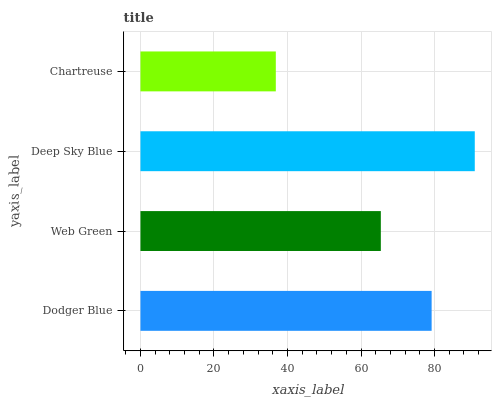Is Chartreuse the minimum?
Answer yes or no. Yes. Is Deep Sky Blue the maximum?
Answer yes or no. Yes. Is Web Green the minimum?
Answer yes or no. No. Is Web Green the maximum?
Answer yes or no. No. Is Dodger Blue greater than Web Green?
Answer yes or no. Yes. Is Web Green less than Dodger Blue?
Answer yes or no. Yes. Is Web Green greater than Dodger Blue?
Answer yes or no. No. Is Dodger Blue less than Web Green?
Answer yes or no. No. Is Dodger Blue the high median?
Answer yes or no. Yes. Is Web Green the low median?
Answer yes or no. Yes. Is Web Green the high median?
Answer yes or no. No. Is Deep Sky Blue the low median?
Answer yes or no. No. 